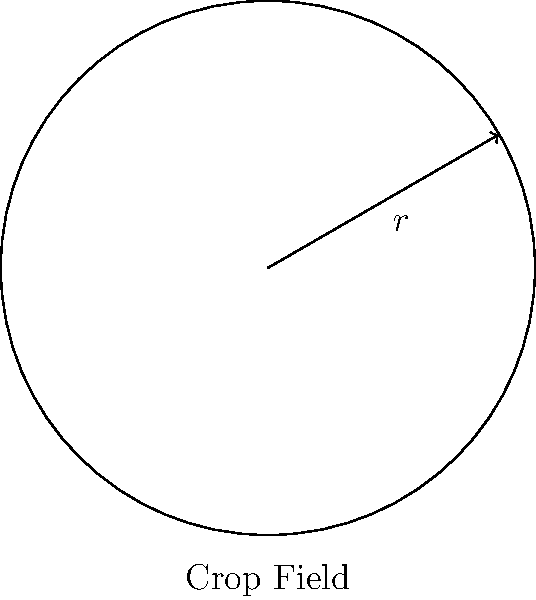As a climate-resilient crop specialist, you're planning a circular crop field designed to withstand extreme weather conditions. If the radius of the field is 100 meters, what is the total area of the crop field in square meters? Use $\pi \approx 3.14$ for your calculations. To calculate the area of a circular crop field, we need to use the formula for the area of a circle:

$$A = \pi r^2$$

Where:
$A$ = Area of the circle
$\pi$ = Pi (approximately 3.14)
$r$ = Radius of the circle

Given:
Radius $(r) = 100$ meters
$\pi \approx 3.14$

Let's substitute these values into the formula:

$$\begin{align}
A &= \pi r^2 \\
&= 3.14 \times (100)^2 \\
&= 3.14 \times 10,000 \\
&= 31,400 \text{ square meters}
\end{align}$$

Therefore, the total area of the circular crop field is 31,400 square meters.
Answer: 31,400 m² 